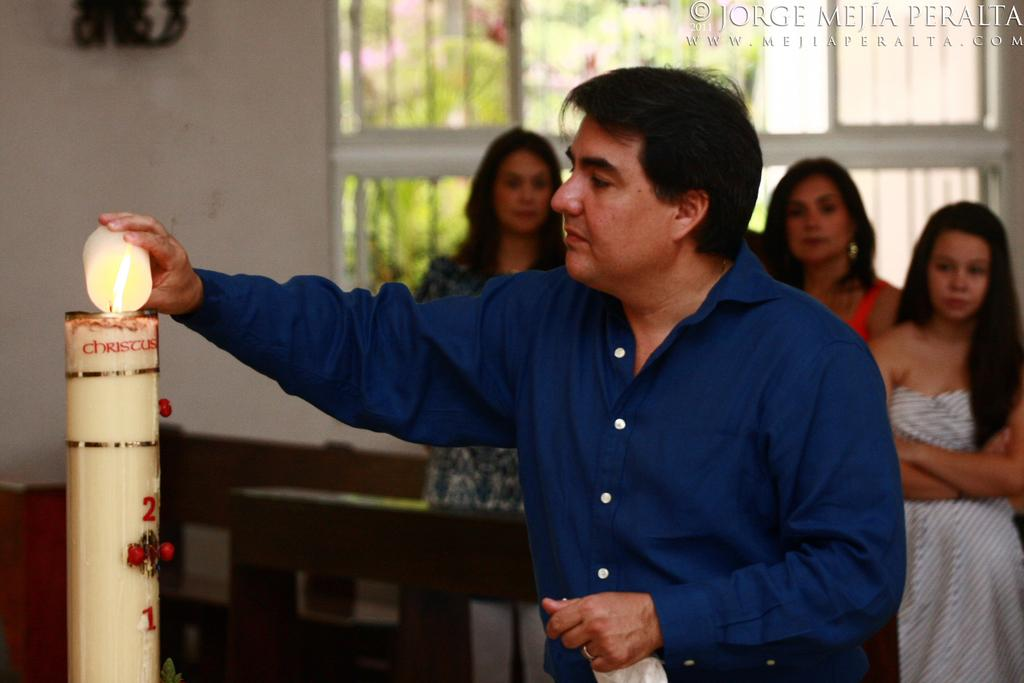What is the person in the image doing? The person is lighting a candle in the image. What is the person wearing? The person is wearing a shirt. Are there any other people in the image? Yes, there are women standing behind the person lighting the candle. What can be seen at the top of the image? There is a window visible at the top of the image. What type of fiction is the person reading in the image? There is no book or any form of fiction present in the image; the person is lighting a candle. How many snakes are visible in the image? There are no snakes present in the image. 